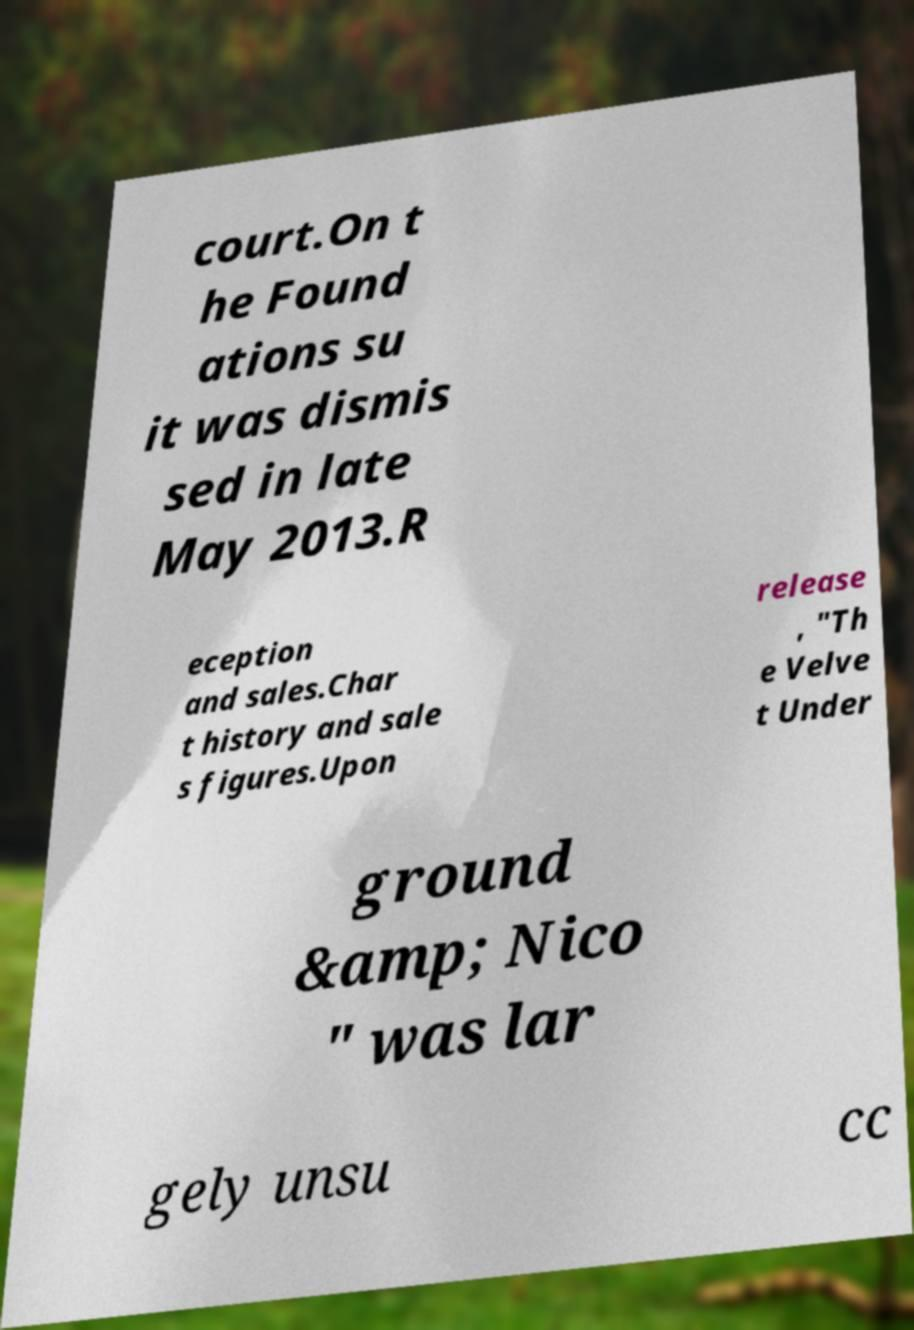What messages or text are displayed in this image? I need them in a readable, typed format. court.On t he Found ations su it was dismis sed in late May 2013.R eception and sales.Char t history and sale s figures.Upon release , "Th e Velve t Under ground &amp; Nico " was lar gely unsu cc 